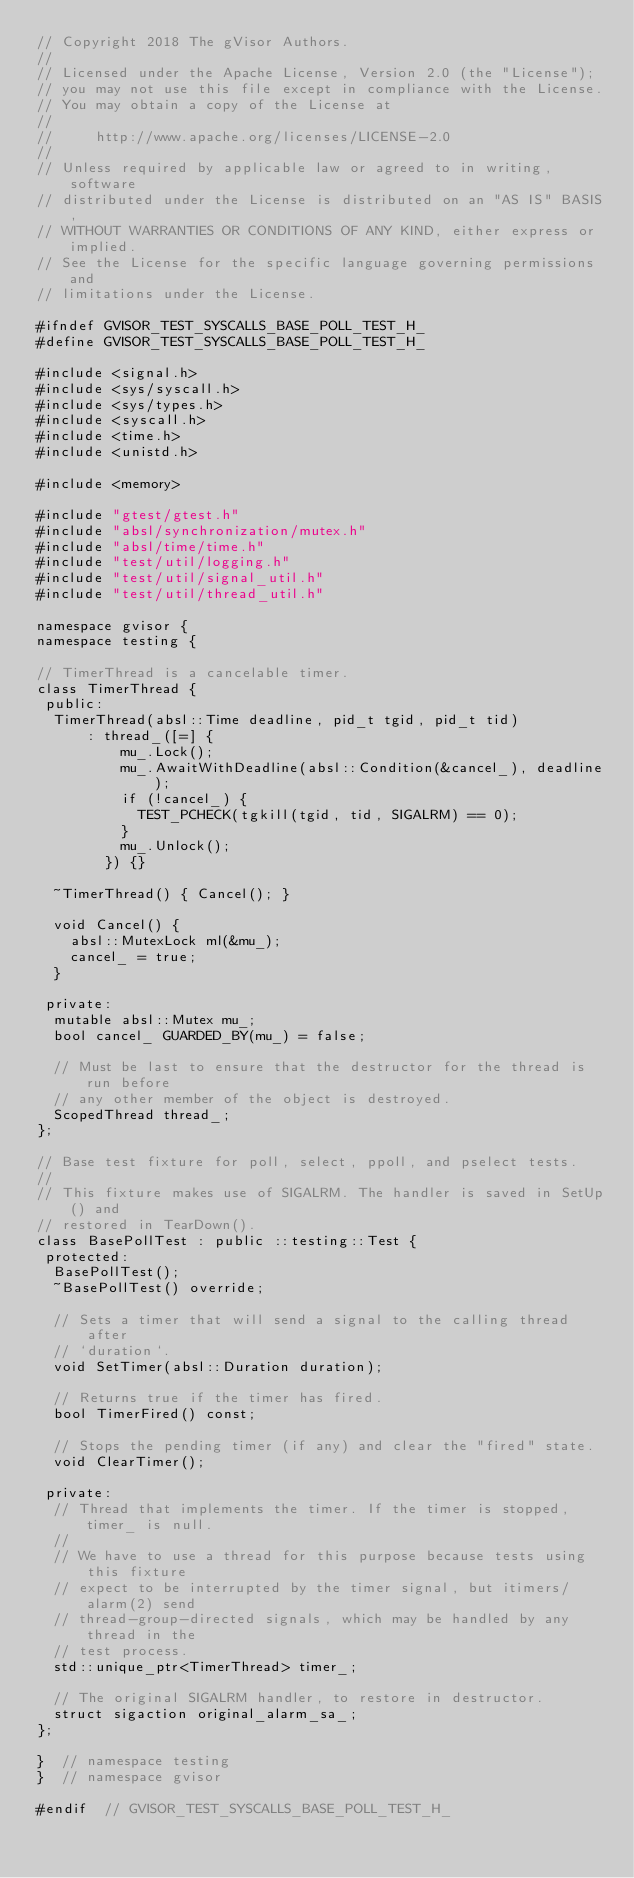Convert code to text. <code><loc_0><loc_0><loc_500><loc_500><_C_>// Copyright 2018 The gVisor Authors.
//
// Licensed under the Apache License, Version 2.0 (the "License");
// you may not use this file except in compliance with the License.
// You may obtain a copy of the License at
//
//     http://www.apache.org/licenses/LICENSE-2.0
//
// Unless required by applicable law or agreed to in writing, software
// distributed under the License is distributed on an "AS IS" BASIS,
// WITHOUT WARRANTIES OR CONDITIONS OF ANY KIND, either express or implied.
// See the License for the specific language governing permissions and
// limitations under the License.

#ifndef GVISOR_TEST_SYSCALLS_BASE_POLL_TEST_H_
#define GVISOR_TEST_SYSCALLS_BASE_POLL_TEST_H_

#include <signal.h>
#include <sys/syscall.h>
#include <sys/types.h>
#include <syscall.h>
#include <time.h>
#include <unistd.h>

#include <memory>

#include "gtest/gtest.h"
#include "absl/synchronization/mutex.h"
#include "absl/time/time.h"
#include "test/util/logging.h"
#include "test/util/signal_util.h"
#include "test/util/thread_util.h"

namespace gvisor {
namespace testing {

// TimerThread is a cancelable timer.
class TimerThread {
 public:
  TimerThread(absl::Time deadline, pid_t tgid, pid_t tid)
      : thread_([=] {
          mu_.Lock();
          mu_.AwaitWithDeadline(absl::Condition(&cancel_), deadline);
          if (!cancel_) {
            TEST_PCHECK(tgkill(tgid, tid, SIGALRM) == 0);
          }
          mu_.Unlock();
        }) {}

  ~TimerThread() { Cancel(); }

  void Cancel() {
    absl::MutexLock ml(&mu_);
    cancel_ = true;
  }

 private:
  mutable absl::Mutex mu_;
  bool cancel_ GUARDED_BY(mu_) = false;

  // Must be last to ensure that the destructor for the thread is run before
  // any other member of the object is destroyed.
  ScopedThread thread_;
};

// Base test fixture for poll, select, ppoll, and pselect tests.
//
// This fixture makes use of SIGALRM. The handler is saved in SetUp() and
// restored in TearDown().
class BasePollTest : public ::testing::Test {
 protected:
  BasePollTest();
  ~BasePollTest() override;

  // Sets a timer that will send a signal to the calling thread after
  // `duration`.
  void SetTimer(absl::Duration duration);

  // Returns true if the timer has fired.
  bool TimerFired() const;

  // Stops the pending timer (if any) and clear the "fired" state.
  void ClearTimer();

 private:
  // Thread that implements the timer. If the timer is stopped, timer_ is null.
  //
  // We have to use a thread for this purpose because tests using this fixture
  // expect to be interrupted by the timer signal, but itimers/alarm(2) send
  // thread-group-directed signals, which may be handled by any thread in the
  // test process.
  std::unique_ptr<TimerThread> timer_;

  // The original SIGALRM handler, to restore in destructor.
  struct sigaction original_alarm_sa_;
};

}  // namespace testing
}  // namespace gvisor

#endif  // GVISOR_TEST_SYSCALLS_BASE_POLL_TEST_H_
</code> 